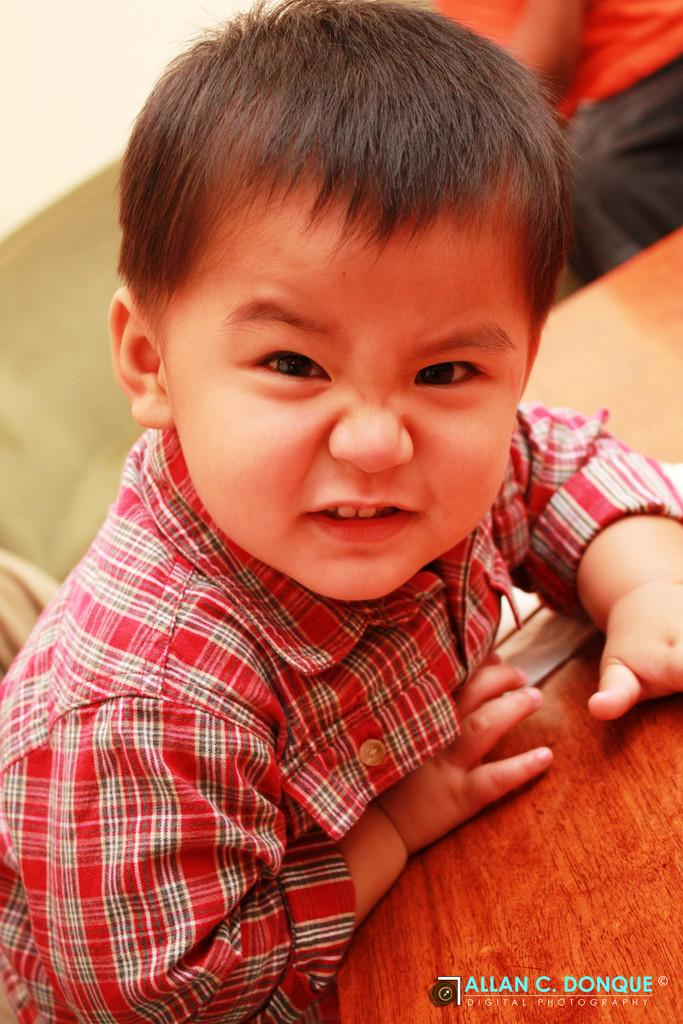What can be seen in the image? There is a person in the image. Can you describe the person's clothing? The person is wearing a dress with red, black, and white colors. What is in front of the person? There is a table in front of the person. Are there any other people visible in the image? Yes, there is another person visible in the background of the image. What is the background person wearing? The background person is also wearing a dress. What type of grain is being harvested in the image? There is no grain or harvesting activity present in the image. How many snakes can be seen slithering around the person's feet in the image? There are no snakes present in the image. 